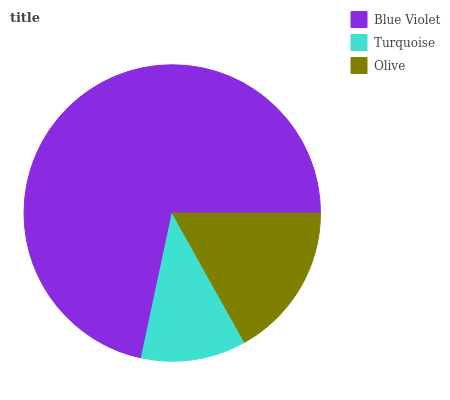Is Turquoise the minimum?
Answer yes or no. Yes. Is Blue Violet the maximum?
Answer yes or no. Yes. Is Olive the minimum?
Answer yes or no. No. Is Olive the maximum?
Answer yes or no. No. Is Olive greater than Turquoise?
Answer yes or no. Yes. Is Turquoise less than Olive?
Answer yes or no. Yes. Is Turquoise greater than Olive?
Answer yes or no. No. Is Olive less than Turquoise?
Answer yes or no. No. Is Olive the high median?
Answer yes or no. Yes. Is Olive the low median?
Answer yes or no. Yes. Is Turquoise the high median?
Answer yes or no. No. Is Blue Violet the low median?
Answer yes or no. No. 